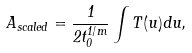<formula> <loc_0><loc_0><loc_500><loc_500>A _ { s c a l e d } = \frac { 1 } { 2 t _ { 0 } ^ { 1 / m } } \int T ( u ) d u ,</formula> 